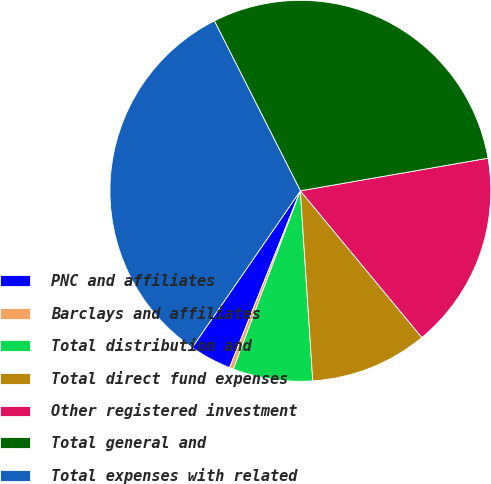Convert chart to OTSL. <chart><loc_0><loc_0><loc_500><loc_500><pie_chart><fcel>PNC and affiliates<fcel>Barclays and affiliates<fcel>Total distribution and<fcel>Total direct fund expenses<fcel>Other registered investment<fcel>Total general and<fcel>Total expenses with related<nl><fcel>3.55%<fcel>0.34%<fcel>6.76%<fcel>9.97%<fcel>16.73%<fcel>29.71%<fcel>32.92%<nl></chart> 